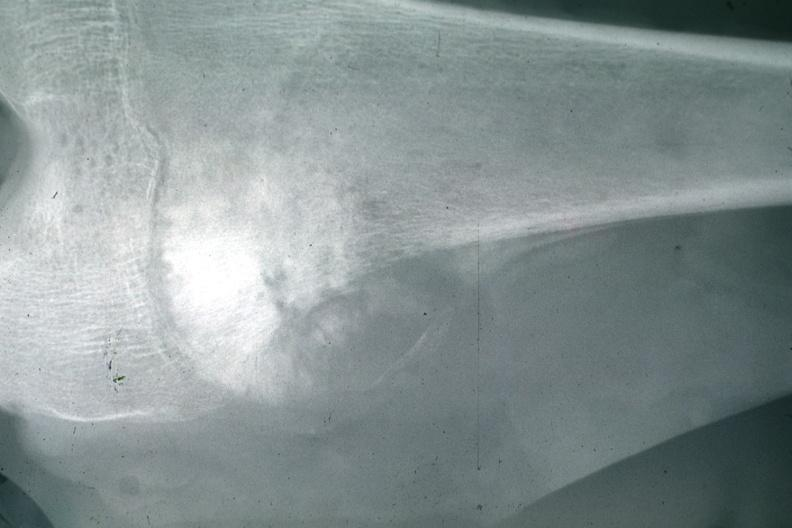what does this image show?
Answer the question using a single word or phrase. X-ray typical lesion 